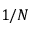<formula> <loc_0><loc_0><loc_500><loc_500>1 / N</formula> 